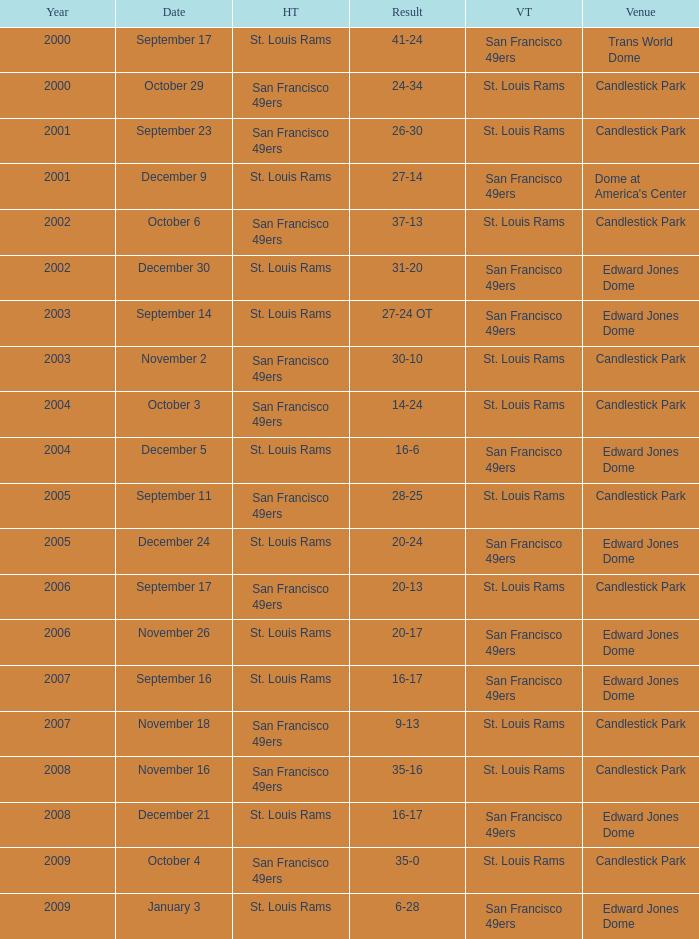What was the Venue on November 26? Edward Jones Dome. 